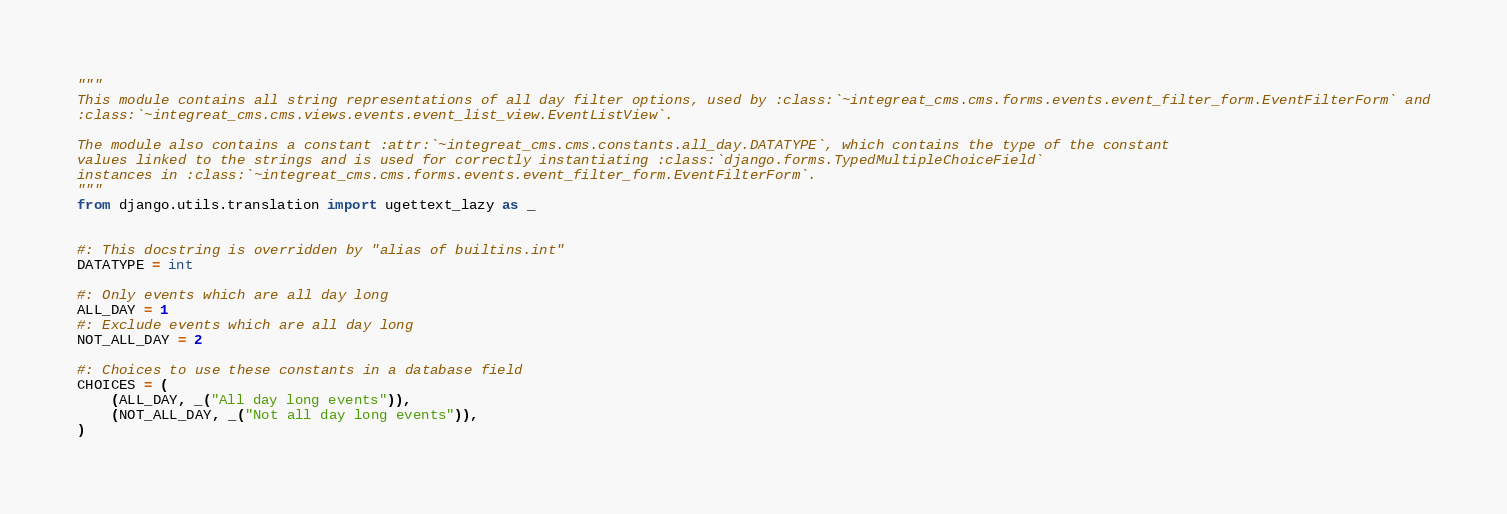Convert code to text. <code><loc_0><loc_0><loc_500><loc_500><_Python_>"""
This module contains all string representations of all day filter options, used by :class:`~integreat_cms.cms.forms.events.event_filter_form.EventFilterForm` and
:class:`~integreat_cms.cms.views.events.event_list_view.EventListView`.

The module also contains a constant :attr:`~integreat_cms.cms.constants.all_day.DATATYPE`, which contains the type of the constant
values linked to the strings and is used for correctly instantiating :class:`django.forms.TypedMultipleChoiceField`
instances in :class:`~integreat_cms.cms.forms.events.event_filter_form.EventFilterForm`.
"""
from django.utils.translation import ugettext_lazy as _


#: This docstring is overridden by "alias of builtins.int"
DATATYPE = int

#: Only events which are all day long
ALL_DAY = 1
#: Exclude events which are all day long
NOT_ALL_DAY = 2

#: Choices to use these constants in a database field
CHOICES = (
    (ALL_DAY, _("All day long events")),
    (NOT_ALL_DAY, _("Not all day long events")),
)
</code> 